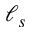<formula> <loc_0><loc_0><loc_500><loc_500>\ell _ { s }</formula> 